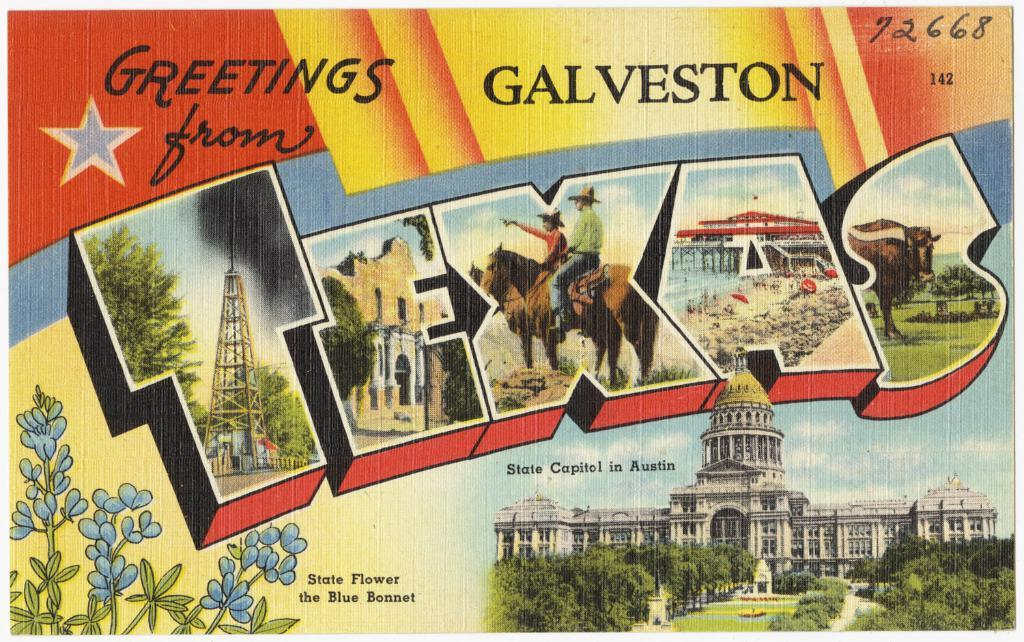What is the main feature of the image? There is a banner in the image. What types of images are present on the banner? The banner contains images of plants, trees, buildings, and horses. What role does the father play in the image? There is no father present in the image; it only features a banner with various images. 